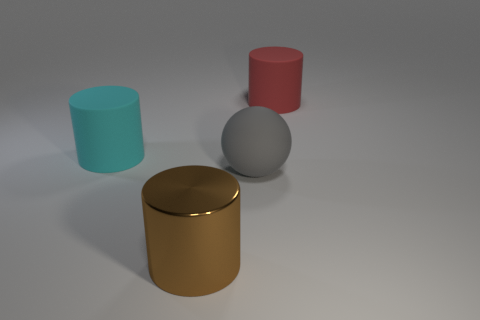Does the big ball have the same material as the thing in front of the gray matte ball?
Offer a terse response. No. What number of things are cylinders to the right of the large cyan matte object or big things behind the cyan rubber object?
Your answer should be very brief. 2. What number of other objects are the same color as the big metallic thing?
Keep it short and to the point. 0. Is the number of brown cylinders that are to the right of the big red matte cylinder greater than the number of big metallic cylinders right of the large brown shiny thing?
Your answer should be very brief. No. Is there anything else that has the same size as the gray ball?
Ensure brevity in your answer.  Yes. How many cylinders are either big brown things or brown rubber objects?
Make the answer very short. 1. How many objects are either big things that are behind the cyan matte object or big purple objects?
Offer a terse response. 1. What is the shape of the big rubber object that is behind the matte cylinder to the left of the rubber object right of the ball?
Ensure brevity in your answer.  Cylinder. What number of other red objects are the same shape as the red matte object?
Provide a short and direct response. 0. Are the gray thing and the large brown cylinder made of the same material?
Your answer should be very brief. No. 